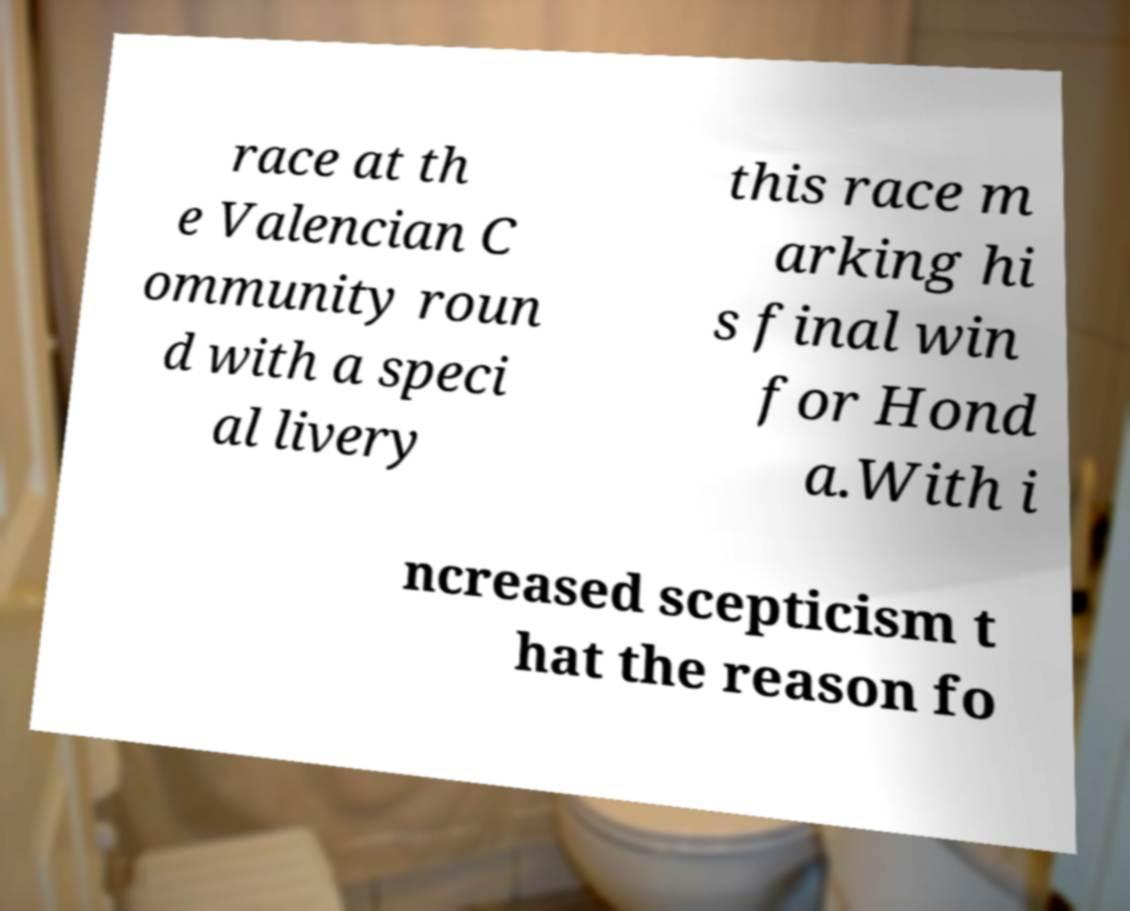Could you extract and type out the text from this image? race at th e Valencian C ommunity roun d with a speci al livery this race m arking hi s final win for Hond a.With i ncreased scepticism t hat the reason fo 